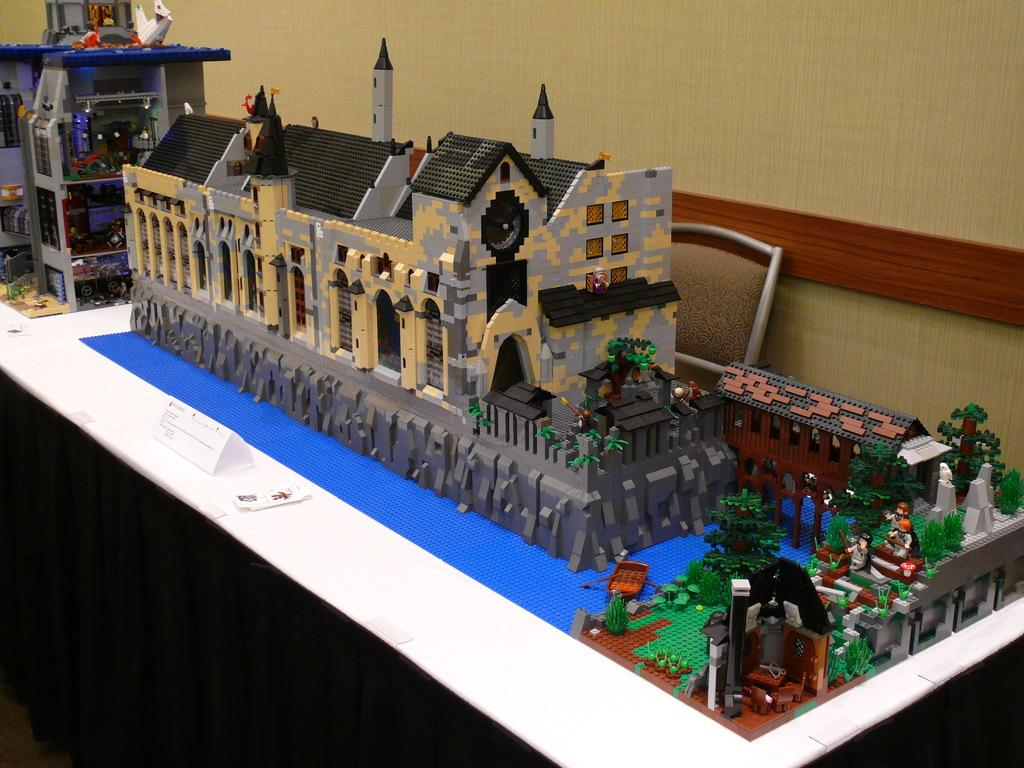What can be found on the table in the image? There are miniatures on the table in the image. What is the small name board used for? The small name board with text is likely used for identification or labeling purposes. What piece of furniture is present in the image? There is a chair in the image. What can be seen in the background of the image? There is a wall in the background of the image. How many brothers are depicted in the image? There are no brothers present in the image; it features miniatures, a name board, a chair, and a wall. What type of memory is being triggered by the image? The image does not depict any specific memory, as it is a still image of objects and a wall. 